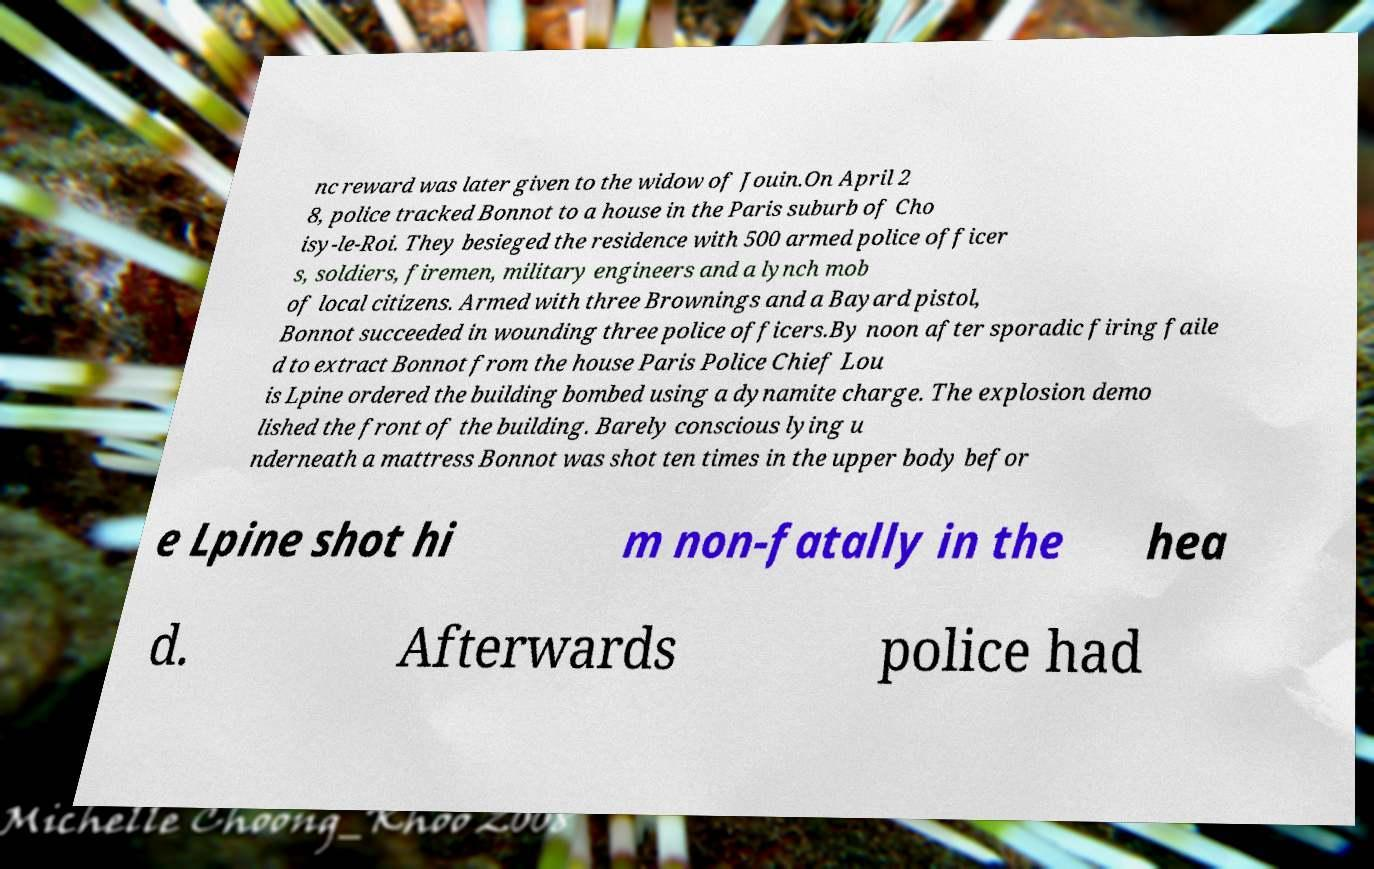For documentation purposes, I need the text within this image transcribed. Could you provide that? nc reward was later given to the widow of Jouin.On April 2 8, police tracked Bonnot to a house in the Paris suburb of Cho isy-le-Roi. They besieged the residence with 500 armed police officer s, soldiers, firemen, military engineers and a lynch mob of local citizens. Armed with three Brownings and a Bayard pistol, Bonnot succeeded in wounding three police officers.By noon after sporadic firing faile d to extract Bonnot from the house Paris Police Chief Lou is Lpine ordered the building bombed using a dynamite charge. The explosion demo lished the front of the building. Barely conscious lying u nderneath a mattress Bonnot was shot ten times in the upper body befor e Lpine shot hi m non-fatally in the hea d. Afterwards police had 